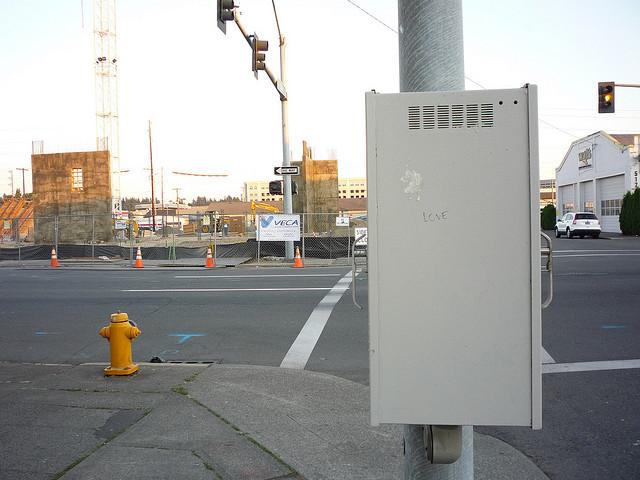How many cones can easily be seen?
Keep it brief. 4. Is the traffic light signaling to slow down?
Keep it brief. Yes. What color is the hydrant?
Quick response, please. Yellow. 